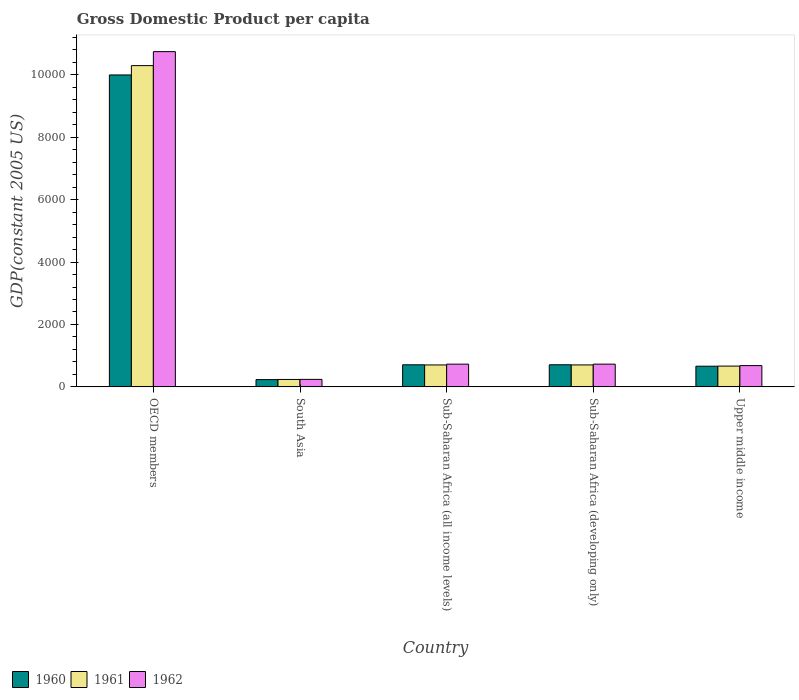How many groups of bars are there?
Your answer should be very brief. 5. Are the number of bars per tick equal to the number of legend labels?
Offer a terse response. Yes. Are the number of bars on each tick of the X-axis equal?
Make the answer very short. Yes. How many bars are there on the 3rd tick from the left?
Provide a short and direct response. 3. What is the label of the 3rd group of bars from the left?
Your answer should be compact. Sub-Saharan Africa (all income levels). What is the GDP per capita in 1962 in OECD members?
Ensure brevity in your answer.  1.07e+04. Across all countries, what is the maximum GDP per capita in 1961?
Provide a short and direct response. 1.03e+04. Across all countries, what is the minimum GDP per capita in 1962?
Offer a very short reply. 240.15. What is the total GDP per capita in 1960 in the graph?
Offer a terse response. 1.23e+04. What is the difference between the GDP per capita in 1960 in OECD members and that in Upper middle income?
Offer a very short reply. 9333.39. What is the difference between the GDP per capita in 1960 in Sub-Saharan Africa (all income levels) and the GDP per capita in 1962 in Sub-Saharan Africa (developing only)?
Keep it short and to the point. -21.41. What is the average GDP per capita in 1961 per country?
Offer a terse response. 2520.57. What is the difference between the GDP per capita of/in 1962 and GDP per capita of/in 1961 in Sub-Saharan Africa (developing only)?
Offer a terse response. 25.67. In how many countries, is the GDP per capita in 1962 greater than 7200 US$?
Give a very brief answer. 1. What is the ratio of the GDP per capita in 1961 in OECD members to that in Sub-Saharan Africa (developing only)?
Your response must be concise. 14.64. Is the difference between the GDP per capita in 1962 in Sub-Saharan Africa (all income levels) and Sub-Saharan Africa (developing only) greater than the difference between the GDP per capita in 1961 in Sub-Saharan Africa (all income levels) and Sub-Saharan Africa (developing only)?
Ensure brevity in your answer.  No. What is the difference between the highest and the second highest GDP per capita in 1960?
Your answer should be compact. 9287.29. What is the difference between the highest and the lowest GDP per capita in 1962?
Offer a very short reply. 1.05e+04. In how many countries, is the GDP per capita in 1962 greater than the average GDP per capita in 1962 taken over all countries?
Offer a terse response. 1. Is the sum of the GDP per capita in 1960 in Sub-Saharan Africa (all income levels) and Upper middle income greater than the maximum GDP per capita in 1961 across all countries?
Give a very brief answer. No. Are all the bars in the graph horizontal?
Give a very brief answer. No. How many countries are there in the graph?
Offer a terse response. 5. What is the difference between two consecutive major ticks on the Y-axis?
Your answer should be very brief. 2000. Are the values on the major ticks of Y-axis written in scientific E-notation?
Offer a terse response. No. Does the graph contain any zero values?
Offer a very short reply. No. Does the graph contain grids?
Ensure brevity in your answer.  No. How are the legend labels stacked?
Offer a very short reply. Horizontal. What is the title of the graph?
Offer a terse response. Gross Domestic Product per capita. What is the label or title of the X-axis?
Your answer should be very brief. Country. What is the label or title of the Y-axis?
Your response must be concise. GDP(constant 2005 US). What is the GDP(constant 2005 US) in 1960 in OECD members?
Ensure brevity in your answer.  9995.33. What is the GDP(constant 2005 US) of 1961 in OECD members?
Your answer should be compact. 1.03e+04. What is the GDP(constant 2005 US) of 1962 in OECD members?
Provide a succinct answer. 1.07e+04. What is the GDP(constant 2005 US) in 1960 in South Asia?
Offer a very short reply. 232.78. What is the GDP(constant 2005 US) in 1961 in South Asia?
Your answer should be very brief. 237.38. What is the GDP(constant 2005 US) of 1962 in South Asia?
Give a very brief answer. 240.15. What is the GDP(constant 2005 US) in 1960 in Sub-Saharan Africa (all income levels)?
Your answer should be very brief. 707.4. What is the GDP(constant 2005 US) of 1961 in Sub-Saharan Africa (all income levels)?
Keep it short and to the point. 702.48. What is the GDP(constant 2005 US) of 1962 in Sub-Saharan Africa (all income levels)?
Your answer should be compact. 728.15. What is the GDP(constant 2005 US) of 1960 in Sub-Saharan Africa (developing only)?
Keep it short and to the point. 708.03. What is the GDP(constant 2005 US) in 1961 in Sub-Saharan Africa (developing only)?
Your answer should be very brief. 703.14. What is the GDP(constant 2005 US) of 1962 in Sub-Saharan Africa (developing only)?
Offer a very short reply. 728.81. What is the GDP(constant 2005 US) in 1960 in Upper middle income?
Ensure brevity in your answer.  661.94. What is the GDP(constant 2005 US) of 1961 in Upper middle income?
Offer a terse response. 665.9. What is the GDP(constant 2005 US) of 1962 in Upper middle income?
Your response must be concise. 681.59. Across all countries, what is the maximum GDP(constant 2005 US) in 1960?
Offer a very short reply. 9995.33. Across all countries, what is the maximum GDP(constant 2005 US) of 1961?
Provide a short and direct response. 1.03e+04. Across all countries, what is the maximum GDP(constant 2005 US) of 1962?
Offer a very short reply. 1.07e+04. Across all countries, what is the minimum GDP(constant 2005 US) of 1960?
Give a very brief answer. 232.78. Across all countries, what is the minimum GDP(constant 2005 US) of 1961?
Provide a short and direct response. 237.38. Across all countries, what is the minimum GDP(constant 2005 US) of 1962?
Keep it short and to the point. 240.15. What is the total GDP(constant 2005 US) in 1960 in the graph?
Make the answer very short. 1.23e+04. What is the total GDP(constant 2005 US) in 1961 in the graph?
Your answer should be compact. 1.26e+04. What is the total GDP(constant 2005 US) of 1962 in the graph?
Offer a very short reply. 1.31e+04. What is the difference between the GDP(constant 2005 US) in 1960 in OECD members and that in South Asia?
Make the answer very short. 9762.55. What is the difference between the GDP(constant 2005 US) in 1961 in OECD members and that in South Asia?
Make the answer very short. 1.01e+04. What is the difference between the GDP(constant 2005 US) of 1962 in OECD members and that in South Asia?
Give a very brief answer. 1.05e+04. What is the difference between the GDP(constant 2005 US) of 1960 in OECD members and that in Sub-Saharan Africa (all income levels)?
Provide a succinct answer. 9287.92. What is the difference between the GDP(constant 2005 US) of 1961 in OECD members and that in Sub-Saharan Africa (all income levels)?
Keep it short and to the point. 9591.46. What is the difference between the GDP(constant 2005 US) of 1962 in OECD members and that in Sub-Saharan Africa (all income levels)?
Offer a terse response. 1.00e+04. What is the difference between the GDP(constant 2005 US) in 1960 in OECD members and that in Sub-Saharan Africa (developing only)?
Keep it short and to the point. 9287.29. What is the difference between the GDP(constant 2005 US) of 1961 in OECD members and that in Sub-Saharan Africa (developing only)?
Offer a terse response. 9590.8. What is the difference between the GDP(constant 2005 US) of 1962 in OECD members and that in Sub-Saharan Africa (developing only)?
Keep it short and to the point. 1.00e+04. What is the difference between the GDP(constant 2005 US) in 1960 in OECD members and that in Upper middle income?
Give a very brief answer. 9333.39. What is the difference between the GDP(constant 2005 US) in 1961 in OECD members and that in Upper middle income?
Your response must be concise. 9628.04. What is the difference between the GDP(constant 2005 US) of 1962 in OECD members and that in Upper middle income?
Provide a short and direct response. 1.01e+04. What is the difference between the GDP(constant 2005 US) of 1960 in South Asia and that in Sub-Saharan Africa (all income levels)?
Provide a succinct answer. -474.62. What is the difference between the GDP(constant 2005 US) of 1961 in South Asia and that in Sub-Saharan Africa (all income levels)?
Your response must be concise. -465.1. What is the difference between the GDP(constant 2005 US) of 1962 in South Asia and that in Sub-Saharan Africa (all income levels)?
Your response must be concise. -488. What is the difference between the GDP(constant 2005 US) in 1960 in South Asia and that in Sub-Saharan Africa (developing only)?
Offer a terse response. -475.26. What is the difference between the GDP(constant 2005 US) in 1961 in South Asia and that in Sub-Saharan Africa (developing only)?
Keep it short and to the point. -465.76. What is the difference between the GDP(constant 2005 US) in 1962 in South Asia and that in Sub-Saharan Africa (developing only)?
Give a very brief answer. -488.66. What is the difference between the GDP(constant 2005 US) of 1960 in South Asia and that in Upper middle income?
Your response must be concise. -429.16. What is the difference between the GDP(constant 2005 US) of 1961 in South Asia and that in Upper middle income?
Make the answer very short. -428.52. What is the difference between the GDP(constant 2005 US) of 1962 in South Asia and that in Upper middle income?
Make the answer very short. -441.44. What is the difference between the GDP(constant 2005 US) of 1960 in Sub-Saharan Africa (all income levels) and that in Sub-Saharan Africa (developing only)?
Keep it short and to the point. -0.63. What is the difference between the GDP(constant 2005 US) of 1961 in Sub-Saharan Africa (all income levels) and that in Sub-Saharan Africa (developing only)?
Give a very brief answer. -0.66. What is the difference between the GDP(constant 2005 US) of 1962 in Sub-Saharan Africa (all income levels) and that in Sub-Saharan Africa (developing only)?
Offer a terse response. -0.66. What is the difference between the GDP(constant 2005 US) of 1960 in Sub-Saharan Africa (all income levels) and that in Upper middle income?
Your answer should be very brief. 45.47. What is the difference between the GDP(constant 2005 US) of 1961 in Sub-Saharan Africa (all income levels) and that in Upper middle income?
Your answer should be very brief. 36.57. What is the difference between the GDP(constant 2005 US) of 1962 in Sub-Saharan Africa (all income levels) and that in Upper middle income?
Keep it short and to the point. 46.56. What is the difference between the GDP(constant 2005 US) in 1960 in Sub-Saharan Africa (developing only) and that in Upper middle income?
Your answer should be very brief. 46.1. What is the difference between the GDP(constant 2005 US) in 1961 in Sub-Saharan Africa (developing only) and that in Upper middle income?
Keep it short and to the point. 37.24. What is the difference between the GDP(constant 2005 US) of 1962 in Sub-Saharan Africa (developing only) and that in Upper middle income?
Provide a short and direct response. 47.22. What is the difference between the GDP(constant 2005 US) in 1960 in OECD members and the GDP(constant 2005 US) in 1961 in South Asia?
Your answer should be compact. 9757.94. What is the difference between the GDP(constant 2005 US) in 1960 in OECD members and the GDP(constant 2005 US) in 1962 in South Asia?
Provide a succinct answer. 9755.17. What is the difference between the GDP(constant 2005 US) in 1961 in OECD members and the GDP(constant 2005 US) in 1962 in South Asia?
Make the answer very short. 1.01e+04. What is the difference between the GDP(constant 2005 US) in 1960 in OECD members and the GDP(constant 2005 US) in 1961 in Sub-Saharan Africa (all income levels)?
Your answer should be compact. 9292.85. What is the difference between the GDP(constant 2005 US) in 1960 in OECD members and the GDP(constant 2005 US) in 1962 in Sub-Saharan Africa (all income levels)?
Keep it short and to the point. 9267.18. What is the difference between the GDP(constant 2005 US) in 1961 in OECD members and the GDP(constant 2005 US) in 1962 in Sub-Saharan Africa (all income levels)?
Your response must be concise. 9565.79. What is the difference between the GDP(constant 2005 US) of 1960 in OECD members and the GDP(constant 2005 US) of 1961 in Sub-Saharan Africa (developing only)?
Ensure brevity in your answer.  9292.18. What is the difference between the GDP(constant 2005 US) in 1960 in OECD members and the GDP(constant 2005 US) in 1962 in Sub-Saharan Africa (developing only)?
Keep it short and to the point. 9266.51. What is the difference between the GDP(constant 2005 US) in 1961 in OECD members and the GDP(constant 2005 US) in 1962 in Sub-Saharan Africa (developing only)?
Offer a terse response. 9565.13. What is the difference between the GDP(constant 2005 US) of 1960 in OECD members and the GDP(constant 2005 US) of 1961 in Upper middle income?
Make the answer very short. 9329.42. What is the difference between the GDP(constant 2005 US) in 1960 in OECD members and the GDP(constant 2005 US) in 1962 in Upper middle income?
Your answer should be compact. 9313.74. What is the difference between the GDP(constant 2005 US) of 1961 in OECD members and the GDP(constant 2005 US) of 1962 in Upper middle income?
Ensure brevity in your answer.  9612.35. What is the difference between the GDP(constant 2005 US) of 1960 in South Asia and the GDP(constant 2005 US) of 1961 in Sub-Saharan Africa (all income levels)?
Your answer should be very brief. -469.7. What is the difference between the GDP(constant 2005 US) in 1960 in South Asia and the GDP(constant 2005 US) in 1962 in Sub-Saharan Africa (all income levels)?
Your answer should be very brief. -495.37. What is the difference between the GDP(constant 2005 US) of 1961 in South Asia and the GDP(constant 2005 US) of 1962 in Sub-Saharan Africa (all income levels)?
Ensure brevity in your answer.  -490.77. What is the difference between the GDP(constant 2005 US) in 1960 in South Asia and the GDP(constant 2005 US) in 1961 in Sub-Saharan Africa (developing only)?
Keep it short and to the point. -470.36. What is the difference between the GDP(constant 2005 US) of 1960 in South Asia and the GDP(constant 2005 US) of 1962 in Sub-Saharan Africa (developing only)?
Your answer should be very brief. -496.04. What is the difference between the GDP(constant 2005 US) of 1961 in South Asia and the GDP(constant 2005 US) of 1962 in Sub-Saharan Africa (developing only)?
Offer a very short reply. -491.43. What is the difference between the GDP(constant 2005 US) of 1960 in South Asia and the GDP(constant 2005 US) of 1961 in Upper middle income?
Provide a succinct answer. -433.13. What is the difference between the GDP(constant 2005 US) of 1960 in South Asia and the GDP(constant 2005 US) of 1962 in Upper middle income?
Ensure brevity in your answer.  -448.81. What is the difference between the GDP(constant 2005 US) of 1961 in South Asia and the GDP(constant 2005 US) of 1962 in Upper middle income?
Offer a terse response. -444.21. What is the difference between the GDP(constant 2005 US) of 1960 in Sub-Saharan Africa (all income levels) and the GDP(constant 2005 US) of 1961 in Sub-Saharan Africa (developing only)?
Offer a terse response. 4.26. What is the difference between the GDP(constant 2005 US) in 1960 in Sub-Saharan Africa (all income levels) and the GDP(constant 2005 US) in 1962 in Sub-Saharan Africa (developing only)?
Provide a succinct answer. -21.41. What is the difference between the GDP(constant 2005 US) in 1961 in Sub-Saharan Africa (all income levels) and the GDP(constant 2005 US) in 1962 in Sub-Saharan Africa (developing only)?
Give a very brief answer. -26.33. What is the difference between the GDP(constant 2005 US) of 1960 in Sub-Saharan Africa (all income levels) and the GDP(constant 2005 US) of 1961 in Upper middle income?
Ensure brevity in your answer.  41.5. What is the difference between the GDP(constant 2005 US) of 1960 in Sub-Saharan Africa (all income levels) and the GDP(constant 2005 US) of 1962 in Upper middle income?
Give a very brief answer. 25.81. What is the difference between the GDP(constant 2005 US) in 1961 in Sub-Saharan Africa (all income levels) and the GDP(constant 2005 US) in 1962 in Upper middle income?
Keep it short and to the point. 20.89. What is the difference between the GDP(constant 2005 US) of 1960 in Sub-Saharan Africa (developing only) and the GDP(constant 2005 US) of 1961 in Upper middle income?
Give a very brief answer. 42.13. What is the difference between the GDP(constant 2005 US) of 1960 in Sub-Saharan Africa (developing only) and the GDP(constant 2005 US) of 1962 in Upper middle income?
Your response must be concise. 26.45. What is the difference between the GDP(constant 2005 US) of 1961 in Sub-Saharan Africa (developing only) and the GDP(constant 2005 US) of 1962 in Upper middle income?
Offer a very short reply. 21.55. What is the average GDP(constant 2005 US) of 1960 per country?
Ensure brevity in your answer.  2461.1. What is the average GDP(constant 2005 US) in 1961 per country?
Provide a short and direct response. 2520.57. What is the average GDP(constant 2005 US) of 1962 per country?
Your answer should be very brief. 2624.15. What is the difference between the GDP(constant 2005 US) of 1960 and GDP(constant 2005 US) of 1961 in OECD members?
Provide a short and direct response. -298.62. What is the difference between the GDP(constant 2005 US) in 1960 and GDP(constant 2005 US) in 1962 in OECD members?
Offer a terse response. -746.74. What is the difference between the GDP(constant 2005 US) of 1961 and GDP(constant 2005 US) of 1962 in OECD members?
Provide a short and direct response. -448.13. What is the difference between the GDP(constant 2005 US) in 1960 and GDP(constant 2005 US) in 1961 in South Asia?
Provide a short and direct response. -4.6. What is the difference between the GDP(constant 2005 US) in 1960 and GDP(constant 2005 US) in 1962 in South Asia?
Provide a succinct answer. -7.37. What is the difference between the GDP(constant 2005 US) in 1961 and GDP(constant 2005 US) in 1962 in South Asia?
Ensure brevity in your answer.  -2.77. What is the difference between the GDP(constant 2005 US) in 1960 and GDP(constant 2005 US) in 1961 in Sub-Saharan Africa (all income levels)?
Make the answer very short. 4.92. What is the difference between the GDP(constant 2005 US) in 1960 and GDP(constant 2005 US) in 1962 in Sub-Saharan Africa (all income levels)?
Your answer should be compact. -20.75. What is the difference between the GDP(constant 2005 US) of 1961 and GDP(constant 2005 US) of 1962 in Sub-Saharan Africa (all income levels)?
Give a very brief answer. -25.67. What is the difference between the GDP(constant 2005 US) in 1960 and GDP(constant 2005 US) in 1961 in Sub-Saharan Africa (developing only)?
Provide a short and direct response. 4.89. What is the difference between the GDP(constant 2005 US) in 1960 and GDP(constant 2005 US) in 1962 in Sub-Saharan Africa (developing only)?
Give a very brief answer. -20.78. What is the difference between the GDP(constant 2005 US) of 1961 and GDP(constant 2005 US) of 1962 in Sub-Saharan Africa (developing only)?
Offer a terse response. -25.67. What is the difference between the GDP(constant 2005 US) in 1960 and GDP(constant 2005 US) in 1961 in Upper middle income?
Make the answer very short. -3.97. What is the difference between the GDP(constant 2005 US) in 1960 and GDP(constant 2005 US) in 1962 in Upper middle income?
Give a very brief answer. -19.65. What is the difference between the GDP(constant 2005 US) of 1961 and GDP(constant 2005 US) of 1962 in Upper middle income?
Provide a short and direct response. -15.68. What is the ratio of the GDP(constant 2005 US) of 1960 in OECD members to that in South Asia?
Your answer should be very brief. 42.94. What is the ratio of the GDP(constant 2005 US) of 1961 in OECD members to that in South Asia?
Your response must be concise. 43.36. What is the ratio of the GDP(constant 2005 US) in 1962 in OECD members to that in South Asia?
Provide a succinct answer. 44.73. What is the ratio of the GDP(constant 2005 US) of 1960 in OECD members to that in Sub-Saharan Africa (all income levels)?
Provide a short and direct response. 14.13. What is the ratio of the GDP(constant 2005 US) of 1961 in OECD members to that in Sub-Saharan Africa (all income levels)?
Your answer should be compact. 14.65. What is the ratio of the GDP(constant 2005 US) in 1962 in OECD members to that in Sub-Saharan Africa (all income levels)?
Offer a terse response. 14.75. What is the ratio of the GDP(constant 2005 US) of 1960 in OECD members to that in Sub-Saharan Africa (developing only)?
Ensure brevity in your answer.  14.12. What is the ratio of the GDP(constant 2005 US) in 1961 in OECD members to that in Sub-Saharan Africa (developing only)?
Give a very brief answer. 14.64. What is the ratio of the GDP(constant 2005 US) of 1962 in OECD members to that in Sub-Saharan Africa (developing only)?
Your answer should be very brief. 14.74. What is the ratio of the GDP(constant 2005 US) of 1960 in OECD members to that in Upper middle income?
Your answer should be very brief. 15.1. What is the ratio of the GDP(constant 2005 US) in 1961 in OECD members to that in Upper middle income?
Ensure brevity in your answer.  15.46. What is the ratio of the GDP(constant 2005 US) in 1962 in OECD members to that in Upper middle income?
Give a very brief answer. 15.76. What is the ratio of the GDP(constant 2005 US) in 1960 in South Asia to that in Sub-Saharan Africa (all income levels)?
Provide a succinct answer. 0.33. What is the ratio of the GDP(constant 2005 US) in 1961 in South Asia to that in Sub-Saharan Africa (all income levels)?
Provide a succinct answer. 0.34. What is the ratio of the GDP(constant 2005 US) of 1962 in South Asia to that in Sub-Saharan Africa (all income levels)?
Your answer should be very brief. 0.33. What is the ratio of the GDP(constant 2005 US) of 1960 in South Asia to that in Sub-Saharan Africa (developing only)?
Offer a terse response. 0.33. What is the ratio of the GDP(constant 2005 US) in 1961 in South Asia to that in Sub-Saharan Africa (developing only)?
Your response must be concise. 0.34. What is the ratio of the GDP(constant 2005 US) of 1962 in South Asia to that in Sub-Saharan Africa (developing only)?
Offer a terse response. 0.33. What is the ratio of the GDP(constant 2005 US) in 1960 in South Asia to that in Upper middle income?
Provide a succinct answer. 0.35. What is the ratio of the GDP(constant 2005 US) of 1961 in South Asia to that in Upper middle income?
Ensure brevity in your answer.  0.36. What is the ratio of the GDP(constant 2005 US) in 1962 in South Asia to that in Upper middle income?
Give a very brief answer. 0.35. What is the ratio of the GDP(constant 2005 US) in 1962 in Sub-Saharan Africa (all income levels) to that in Sub-Saharan Africa (developing only)?
Make the answer very short. 1. What is the ratio of the GDP(constant 2005 US) in 1960 in Sub-Saharan Africa (all income levels) to that in Upper middle income?
Provide a succinct answer. 1.07. What is the ratio of the GDP(constant 2005 US) in 1961 in Sub-Saharan Africa (all income levels) to that in Upper middle income?
Your answer should be compact. 1.05. What is the ratio of the GDP(constant 2005 US) in 1962 in Sub-Saharan Africa (all income levels) to that in Upper middle income?
Offer a terse response. 1.07. What is the ratio of the GDP(constant 2005 US) in 1960 in Sub-Saharan Africa (developing only) to that in Upper middle income?
Offer a terse response. 1.07. What is the ratio of the GDP(constant 2005 US) in 1961 in Sub-Saharan Africa (developing only) to that in Upper middle income?
Offer a very short reply. 1.06. What is the ratio of the GDP(constant 2005 US) in 1962 in Sub-Saharan Africa (developing only) to that in Upper middle income?
Your answer should be compact. 1.07. What is the difference between the highest and the second highest GDP(constant 2005 US) of 1960?
Provide a succinct answer. 9287.29. What is the difference between the highest and the second highest GDP(constant 2005 US) in 1961?
Give a very brief answer. 9590.8. What is the difference between the highest and the second highest GDP(constant 2005 US) in 1962?
Ensure brevity in your answer.  1.00e+04. What is the difference between the highest and the lowest GDP(constant 2005 US) of 1960?
Your answer should be compact. 9762.55. What is the difference between the highest and the lowest GDP(constant 2005 US) of 1961?
Provide a succinct answer. 1.01e+04. What is the difference between the highest and the lowest GDP(constant 2005 US) of 1962?
Your response must be concise. 1.05e+04. 